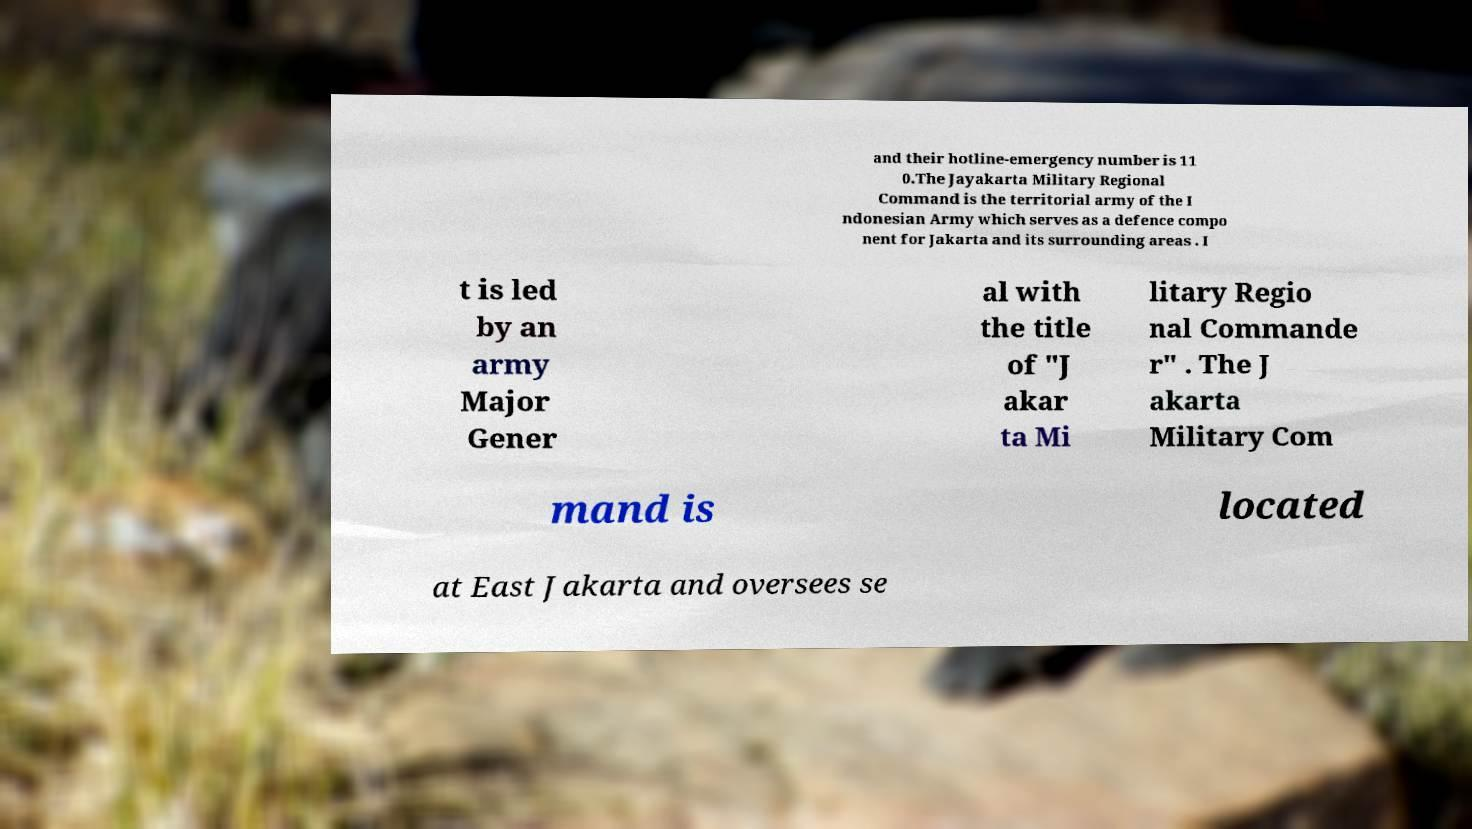There's text embedded in this image that I need extracted. Can you transcribe it verbatim? and their hotline-emergency number is 11 0.The Jayakarta Military Regional Command is the territorial army of the I ndonesian Army which serves as a defence compo nent for Jakarta and its surrounding areas . I t is led by an army Major Gener al with the title of "J akar ta Mi litary Regio nal Commande r" . The J akarta Military Com mand is located at East Jakarta and oversees se 